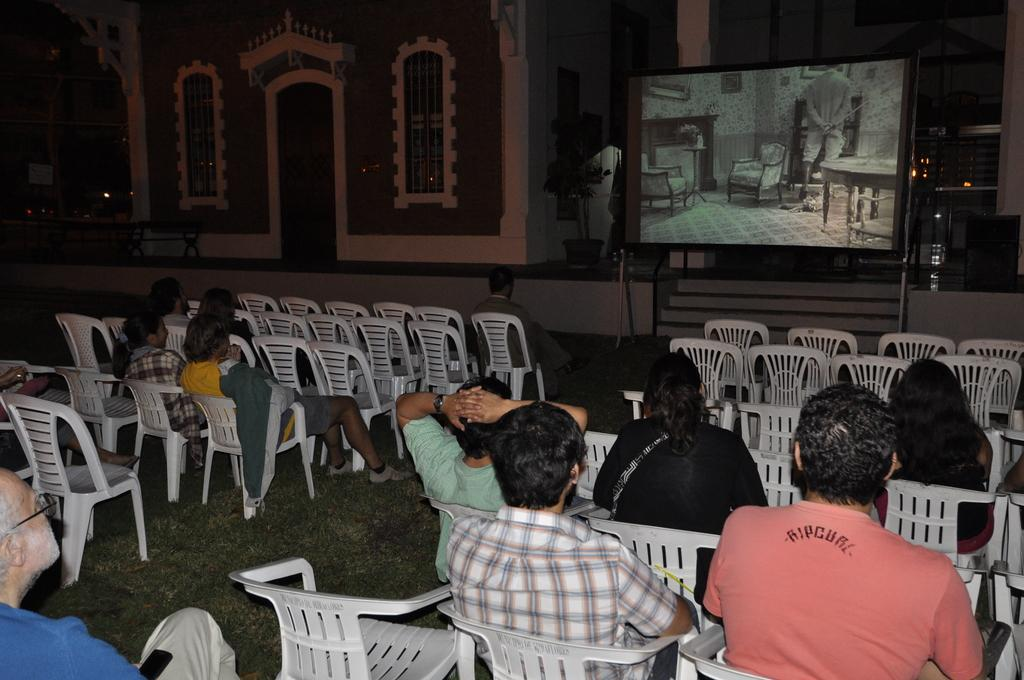What are the people in the image doing? The people in the image are sitting in chairs and watching a projector display screen. Can you describe the gender of the people in the image? There are both men and women in the image. What can be seen in the background of the image? There is a building in the background of the image. What type of design can be seen on the ship in the image? There is no ship present in the image; it features people sitting in chairs and watching a projector display screen. Is there any smoke coming from the projector in the image? There is no smoke visible in the image; it only shows people sitting in chairs and watching a projector display screen. 